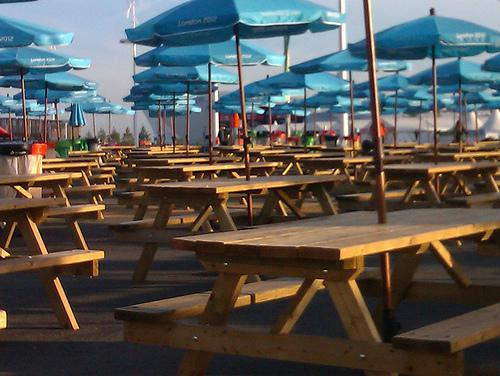Question: when was this picture taken?
Choices:
A. During the day.
B. At night.
C. The morning.
D. During a storm.
Answer with the letter. Answer: A Question: what color are the umbrellas?
Choices:
A. Purple.
B. Blue.
C. Green.
D. Red.
Answer with the letter. Answer: B Question: what are the benches made out of?
Choices:
A. Plastic.
B. Iron.
C. Marble.
D. Wood.
Answer with the letter. Answer: D Question: where does the trash go?
Choices:
A. Trash cans.
B. The garbage dump.
C. Garbage bins with white bags.
D. The trash compacter.
Answer with the letter. Answer: C 